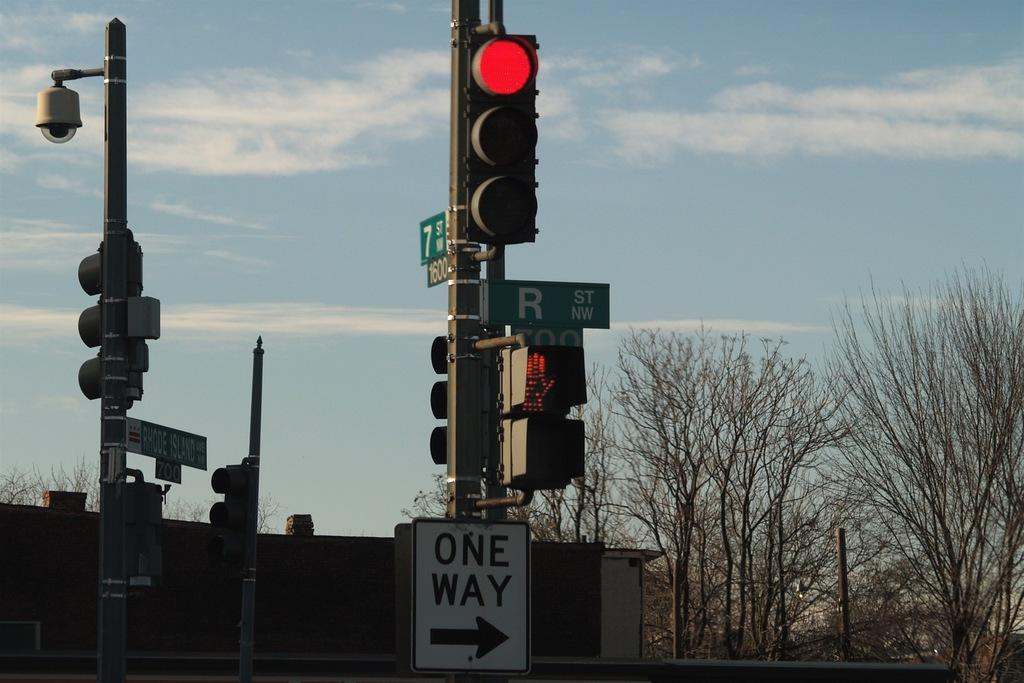<image>
Write a terse but informative summary of the picture. a one way street sign at nw r street and 7th street w 